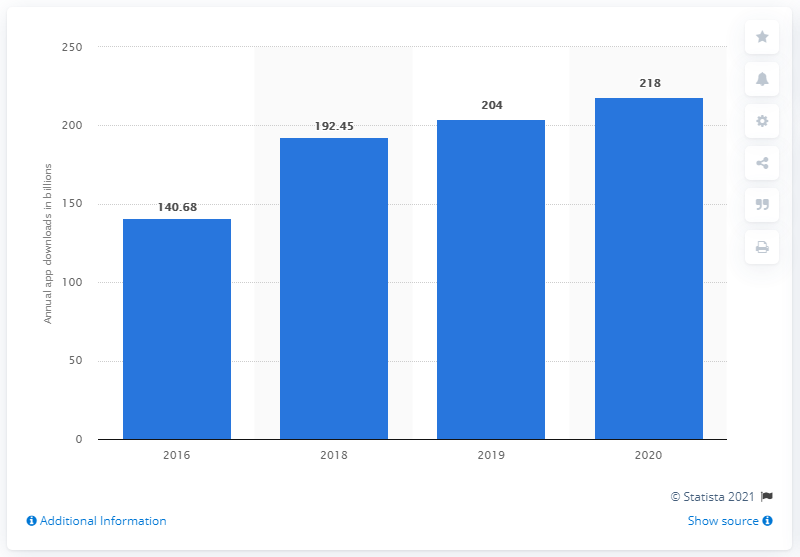Identify some key points in this picture. In 2016, there were 140.68 million app downloads. In the most recent year, consumers downloaded 218 apps on average. 